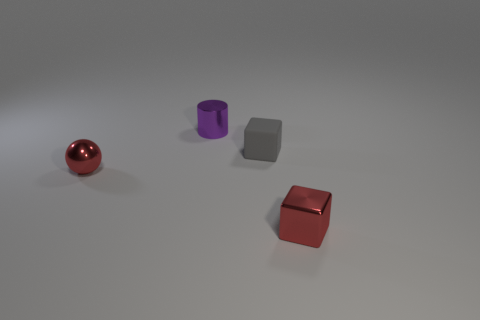Can you describe the texture of the objects shown in the image? Certainly. The image showcases three objects with distinct textures: the spherical object has a shiny, reflective surface; the cylinder has a matte finish, diffusing the light evenly; and the cube shows specular highlights indicating a somewhat glossy texture. 